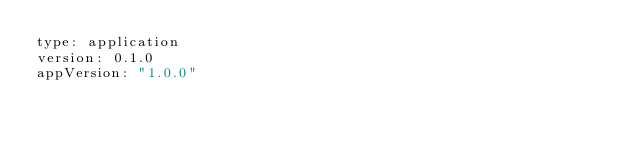<code> <loc_0><loc_0><loc_500><loc_500><_YAML_>type: application
version: 0.1.0
appVersion: "1.0.0"
</code> 